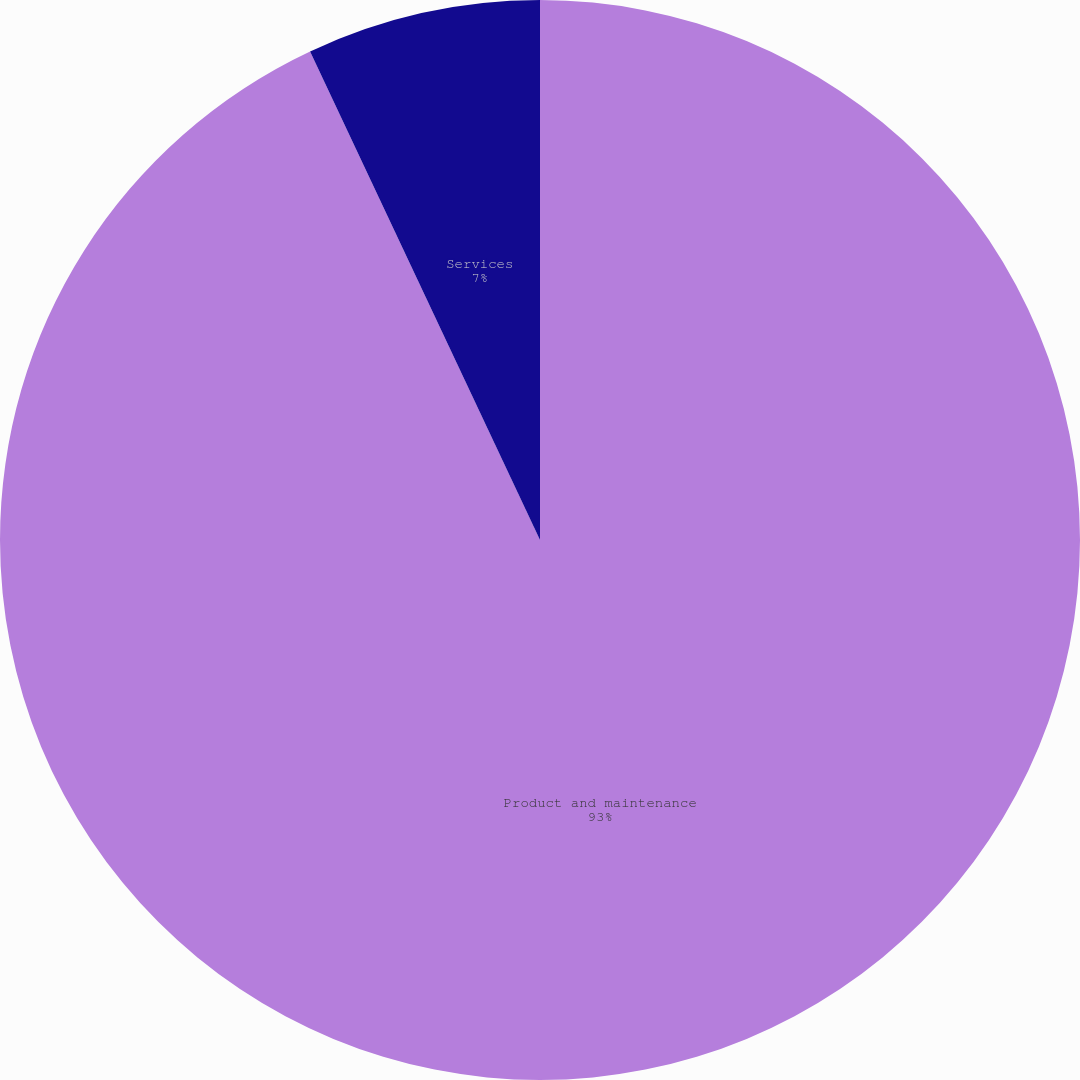<chart> <loc_0><loc_0><loc_500><loc_500><pie_chart><fcel>Product and maintenance<fcel>Services<nl><fcel>93.0%<fcel>7.0%<nl></chart> 